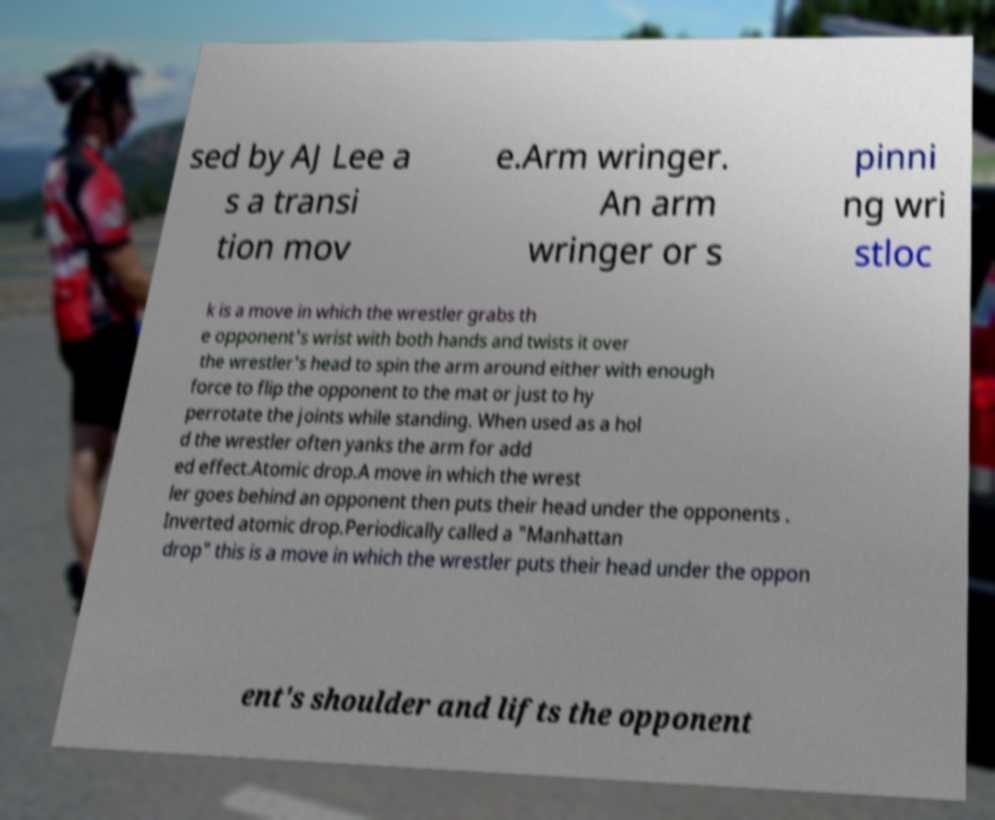There's text embedded in this image that I need extracted. Can you transcribe it verbatim? sed by AJ Lee a s a transi tion mov e.Arm wringer. An arm wringer or s pinni ng wri stloc k is a move in which the wrestler grabs th e opponent's wrist with both hands and twists it over the wrestler's head to spin the arm around either with enough force to flip the opponent to the mat or just to hy perrotate the joints while standing. When used as a hol d the wrestler often yanks the arm for add ed effect.Atomic drop.A move in which the wrest ler goes behind an opponent then puts their head under the opponents . Inverted atomic drop.Periodically called a "Manhattan drop" this is a move in which the wrestler puts their head under the oppon ent's shoulder and lifts the opponent 